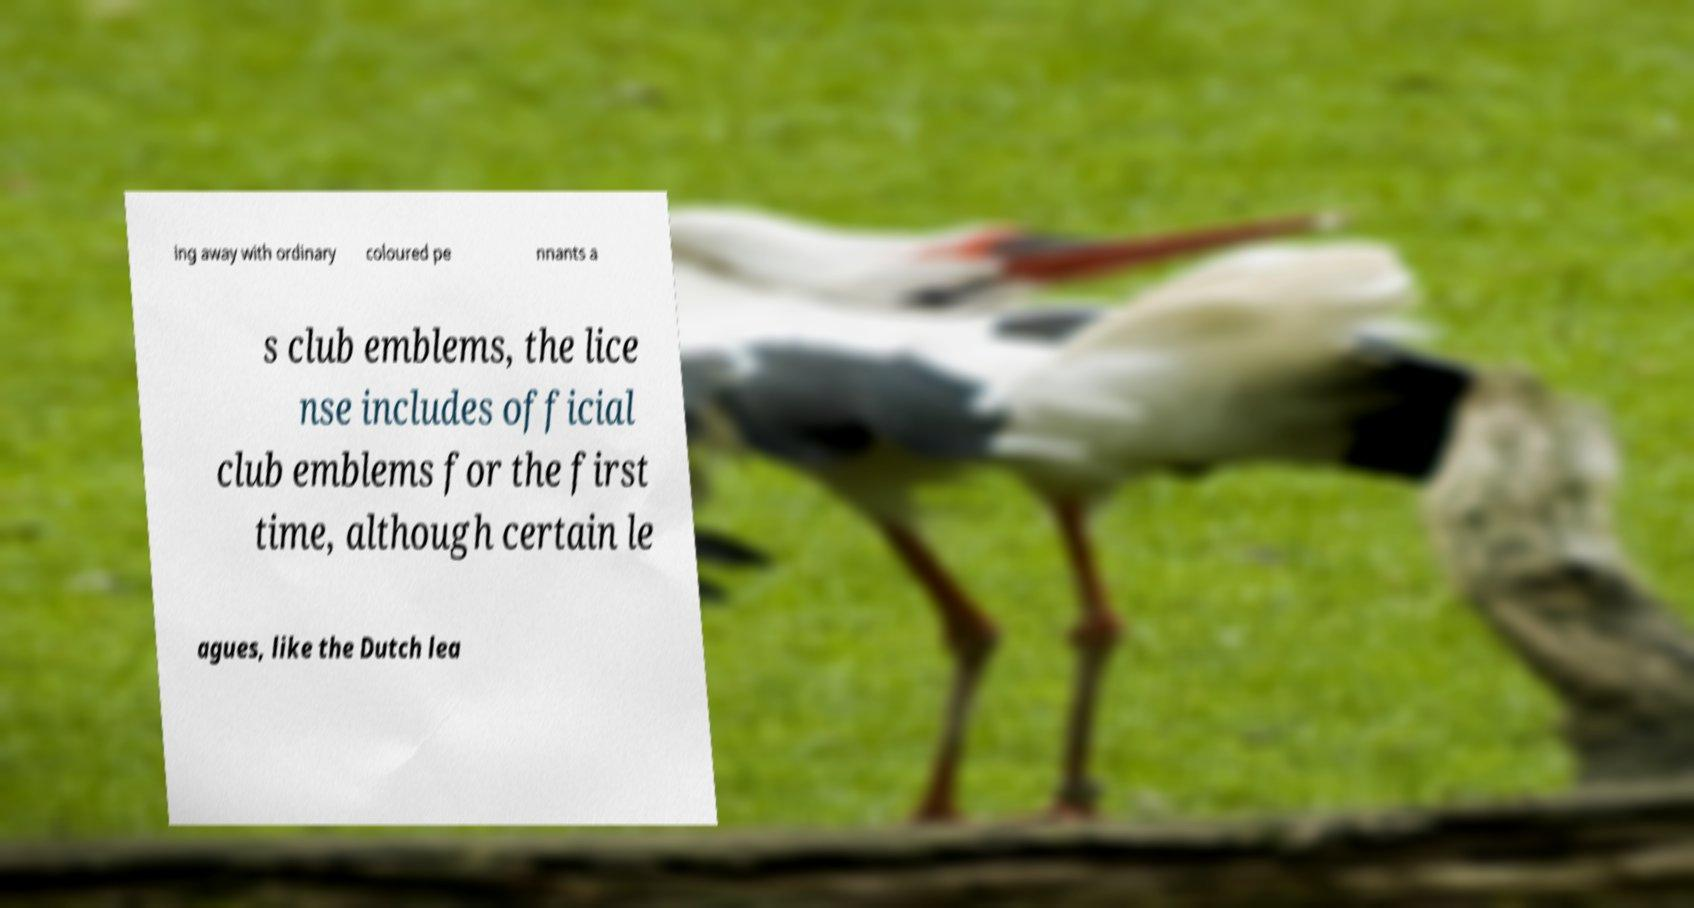Could you extract and type out the text from this image? ing away with ordinary coloured pe nnants a s club emblems, the lice nse includes official club emblems for the first time, although certain le agues, like the Dutch lea 